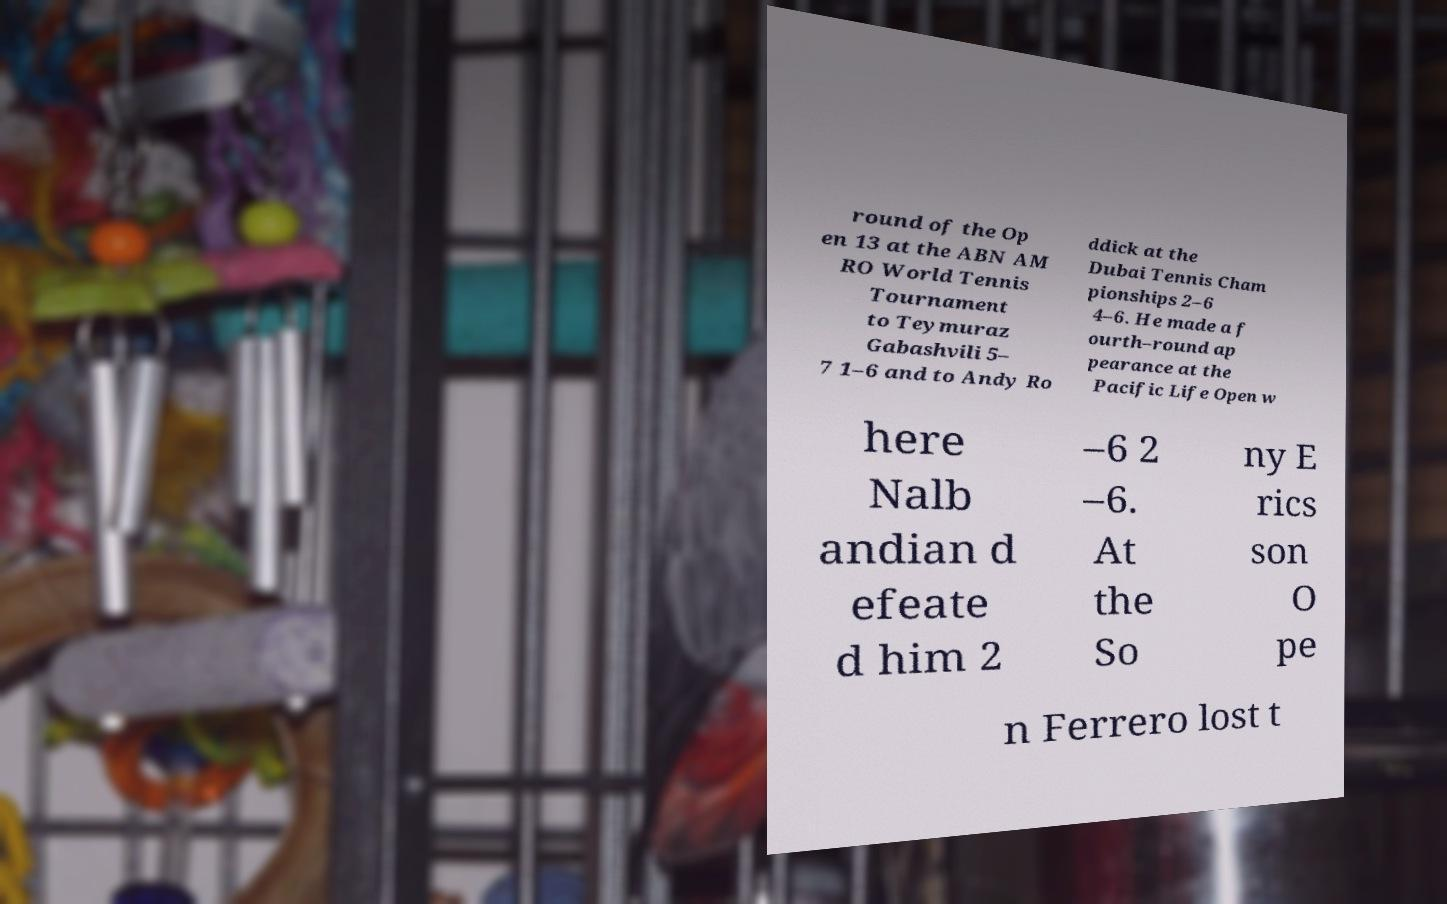For documentation purposes, I need the text within this image transcribed. Could you provide that? round of the Op en 13 at the ABN AM RO World Tennis Tournament to Teymuraz Gabashvili 5– 7 1–6 and to Andy Ro ddick at the Dubai Tennis Cham pionships 2–6 4–6. He made a f ourth–round ap pearance at the Pacific Life Open w here Nalb andian d efeate d him 2 –6 2 –6. At the So ny E rics son O pe n Ferrero lost t 